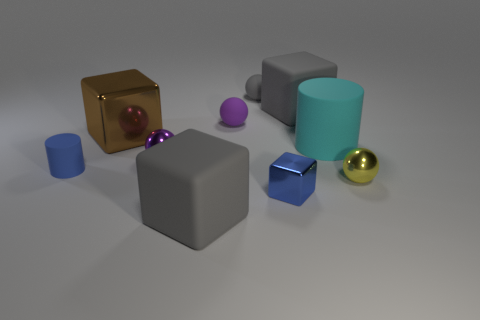Subtract 1 balls. How many balls are left? 3 Subtract all balls. How many objects are left? 6 Subtract 1 cyan cylinders. How many objects are left? 9 Subtract all large brown things. Subtract all small gray shiny cubes. How many objects are left? 9 Add 4 large cylinders. How many large cylinders are left? 5 Add 1 purple rubber things. How many purple rubber things exist? 2 